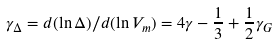<formula> <loc_0><loc_0><loc_500><loc_500>\gamma _ { \Delta } = d ( \ln \Delta ) / d ( \ln V _ { m } ) = 4 \gamma - \frac { 1 } { 3 } + \frac { 1 } { 2 } \gamma _ { G }</formula> 